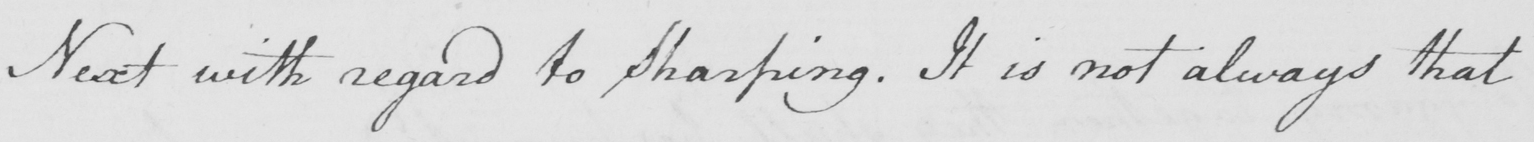What is written in this line of handwriting? Next with regard to Sharping . It is not always that 